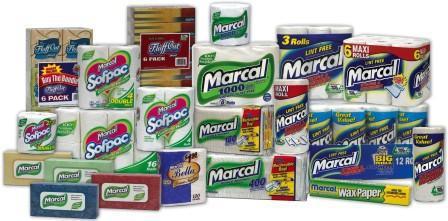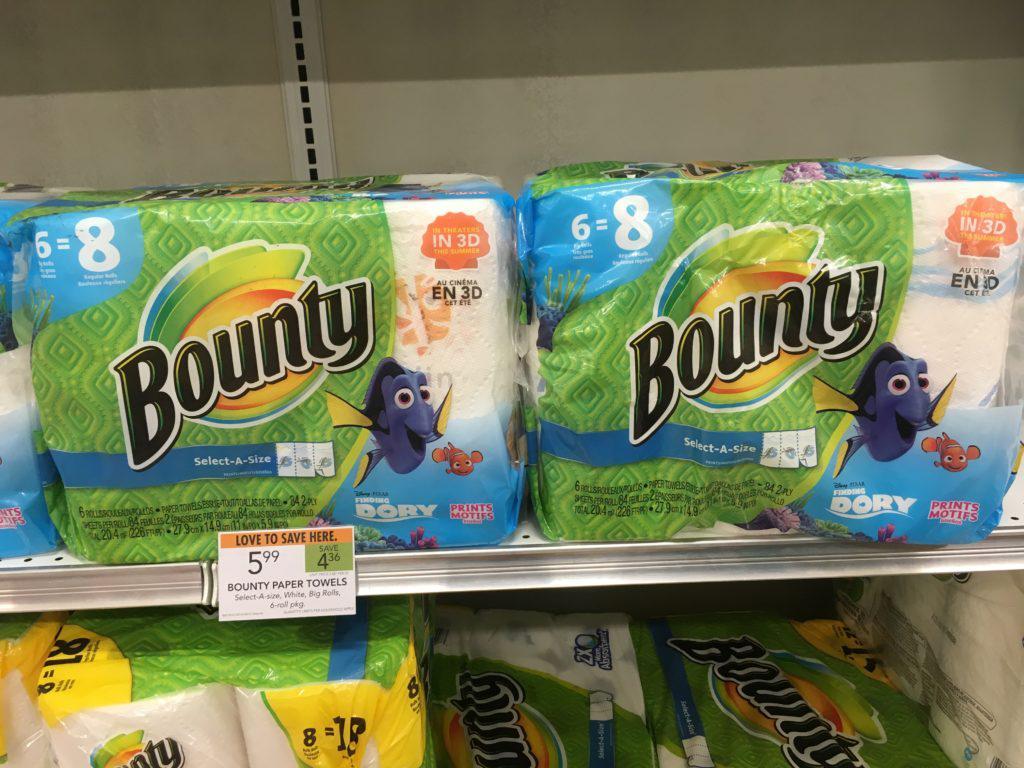The first image is the image on the left, the second image is the image on the right. For the images displayed, is the sentence "at least one image has the price tags on the shelf" factually correct? Answer yes or no. Yes. 